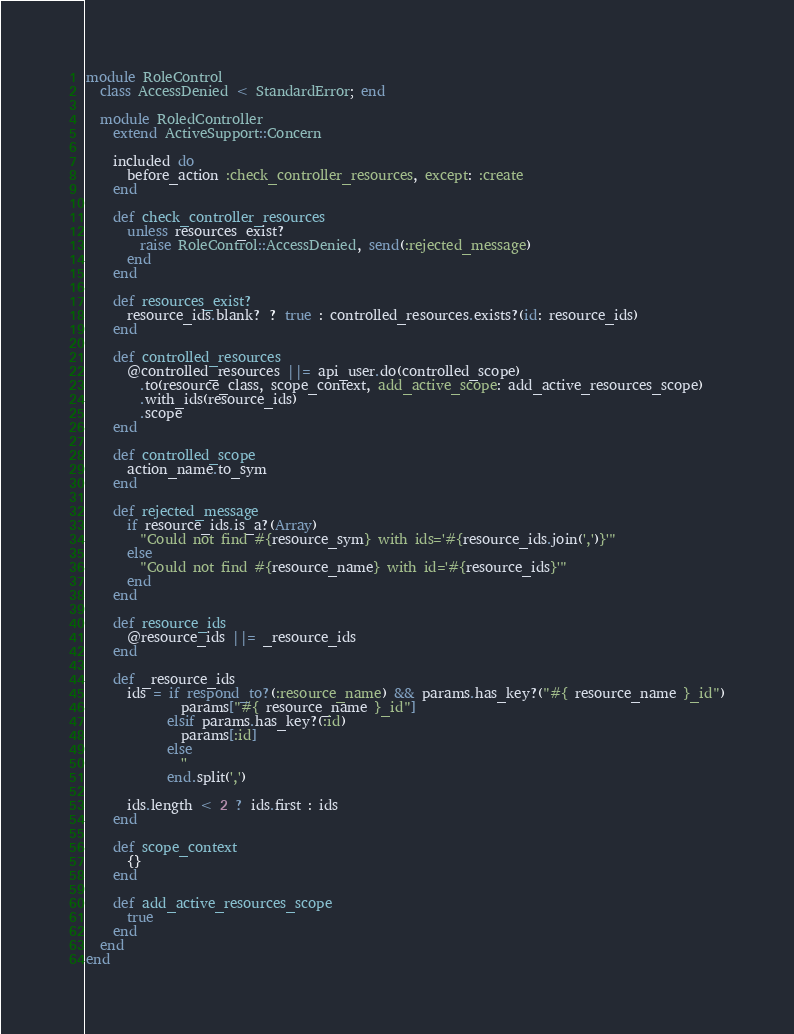<code> <loc_0><loc_0><loc_500><loc_500><_Ruby_>module RoleControl
  class AccessDenied < StandardError; end

  module RoledController
    extend ActiveSupport::Concern

    included do
      before_action :check_controller_resources, except: :create
    end

    def check_controller_resources
      unless resources_exist?
        raise RoleControl::AccessDenied, send(:rejected_message)
      end
    end

    def resources_exist?
      resource_ids.blank? ? true : controlled_resources.exists?(id: resource_ids)
    end

    def controlled_resources
      @controlled_resources ||= api_user.do(controlled_scope)
        .to(resource_class, scope_context, add_active_scope: add_active_resources_scope)
        .with_ids(resource_ids)
        .scope
    end

    def controlled_scope
      action_name.to_sym
    end

    def rejected_message
      if resource_ids.is_a?(Array)
        "Could not find #{resource_sym} with ids='#{resource_ids.join(',')}'"
      else
        "Could not find #{resource_name} with id='#{resource_ids}'"
      end
    end

    def resource_ids
      @resource_ids ||= _resource_ids
    end

    def _resource_ids
      ids = if respond_to?(:resource_name) && params.has_key?("#{ resource_name }_id")
              params["#{ resource_name }_id"]
            elsif params.has_key?(:id)
              params[:id]
            else
              ''
            end.split(',')

      ids.length < 2 ? ids.first : ids
    end

    def scope_context
      {}
    end

    def add_active_resources_scope
      true
    end
  end
end
</code> 